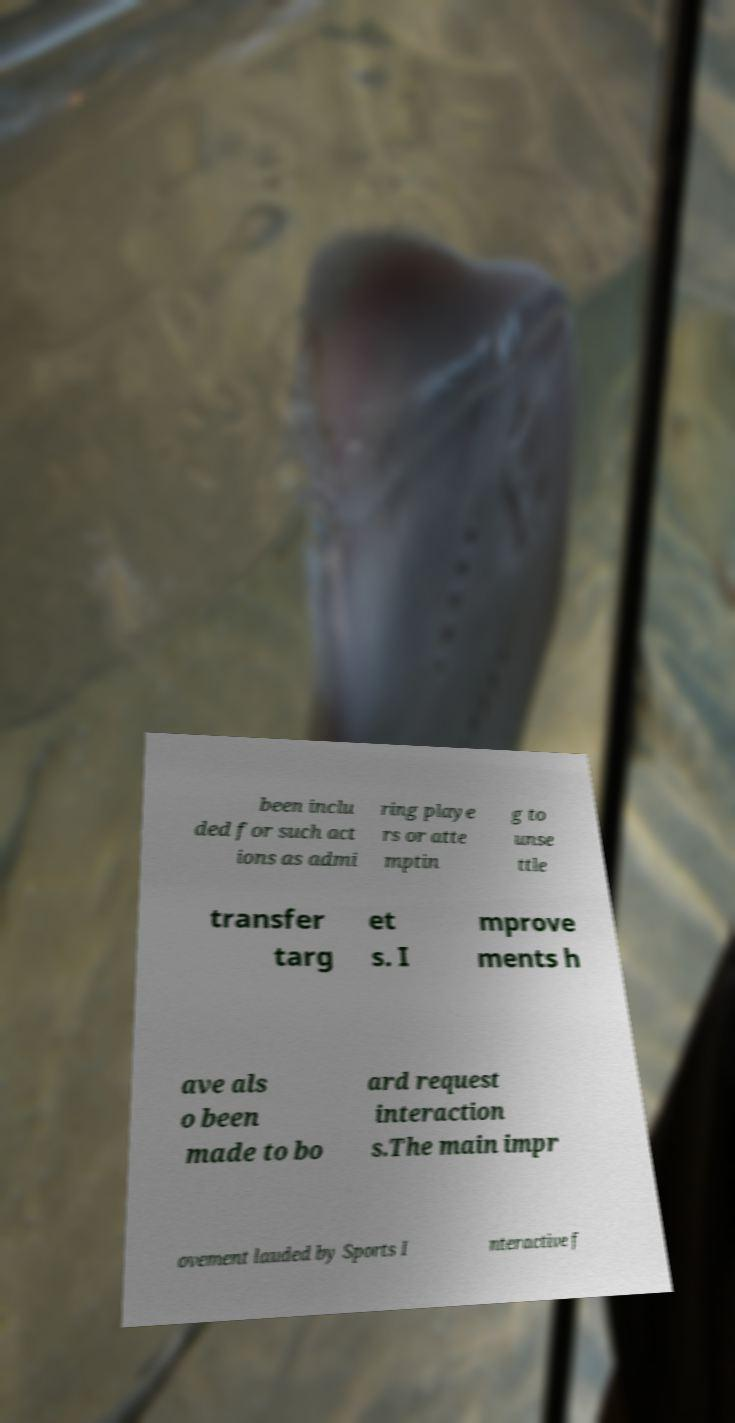Could you extract and type out the text from this image? been inclu ded for such act ions as admi ring playe rs or atte mptin g to unse ttle transfer targ et s. I mprove ments h ave als o been made to bo ard request interaction s.The main impr ovement lauded by Sports I nteractive f 